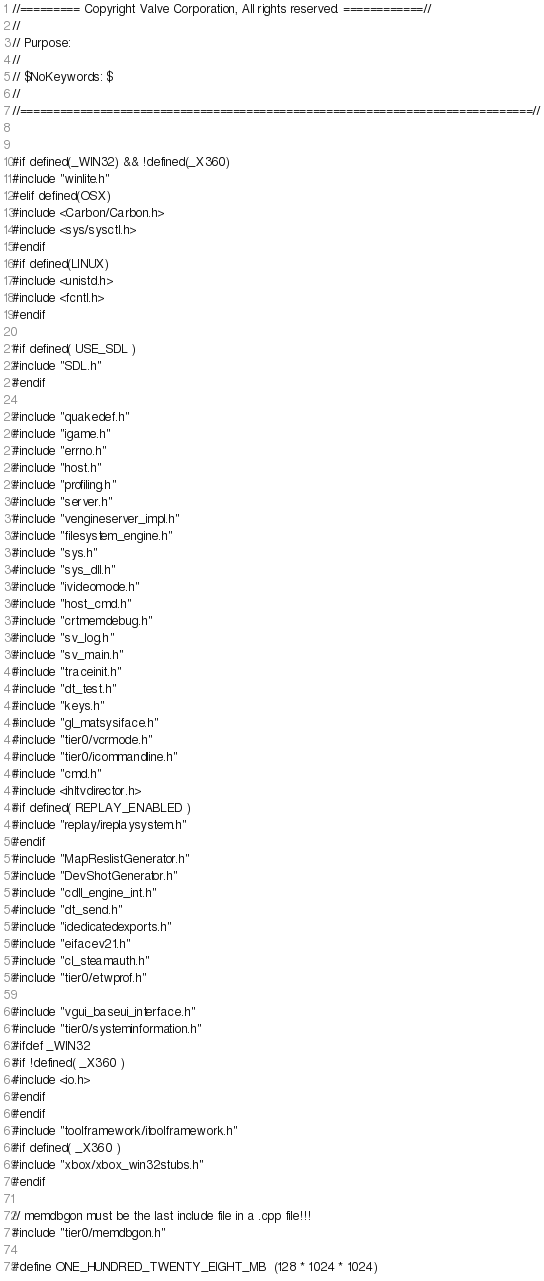<code> <loc_0><loc_0><loc_500><loc_500><_C++_>//========= Copyright Valve Corporation, All rights reserved. ============//
//
// Purpose: 
//
// $NoKeywords: $
//
//=============================================================================//


#if defined(_WIN32) && !defined(_X360)
#include "winlite.h"
#elif defined(OSX)
#include <Carbon/Carbon.h>
#include <sys/sysctl.h>
#endif
#if defined(LINUX)
#include <unistd.h>
#include <fcntl.h>
#endif

#if defined( USE_SDL )
#include "SDL.h"
#endif

#include "quakedef.h"
#include "igame.h"
#include "errno.h"
#include "host.h"
#include "profiling.h"
#include "server.h"
#include "vengineserver_impl.h"
#include "filesystem_engine.h"
#include "sys.h"
#include "sys_dll.h"
#include "ivideomode.h"
#include "host_cmd.h"
#include "crtmemdebug.h"
#include "sv_log.h"
#include "sv_main.h"
#include "traceinit.h"
#include "dt_test.h"
#include "keys.h"
#include "gl_matsysiface.h"
#include "tier0/vcrmode.h"
#include "tier0/icommandline.h"
#include "cmd.h"
#include <ihltvdirector.h>
#if defined( REPLAY_ENABLED )
#include "replay/ireplaysystem.h"
#endif
#include "MapReslistGenerator.h"
#include "DevShotGenerator.h"
#include "cdll_engine_int.h"
#include "dt_send.h"
#include "idedicatedexports.h"
#include "eifacev21.h"
#include "cl_steamauth.h"
#include "tier0/etwprof.h"

#include "vgui_baseui_interface.h"
#include "tier0/systeminformation.h"
#ifdef _WIN32
#if !defined( _X360 )
#include <io.h>
#endif
#endif
#include "toolframework/itoolframework.h"
#if defined( _X360 )
#include "xbox/xbox_win32stubs.h"
#endif

// memdbgon must be the last include file in a .cpp file!!!
#include "tier0/memdbgon.h"

#define ONE_HUNDRED_TWENTY_EIGHT_MB	(128 * 1024 * 1024)
</code> 